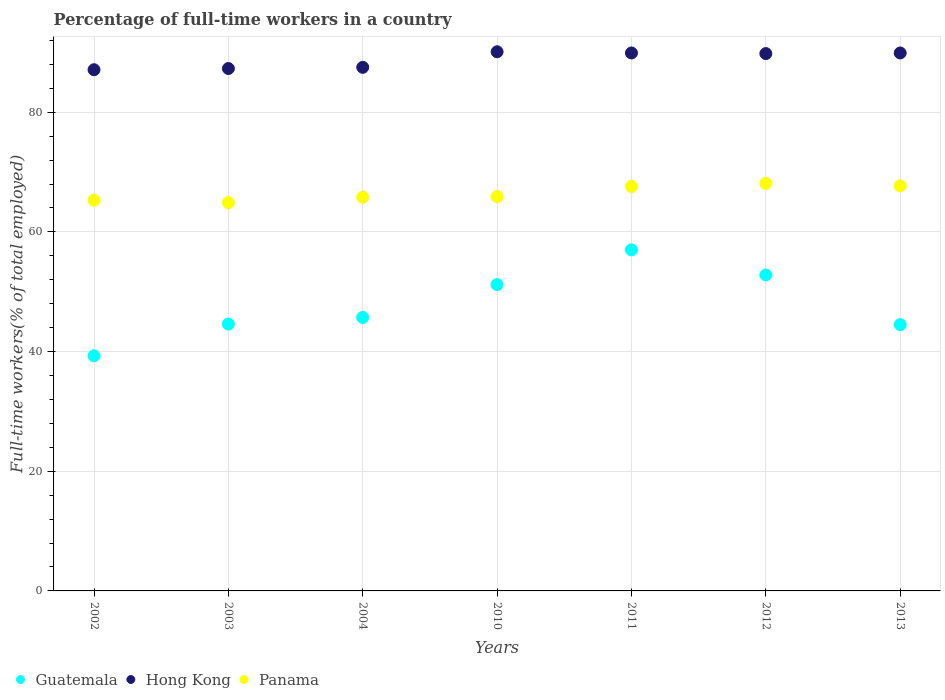What is the percentage of full-time workers in Panama in 2011?
Offer a terse response. 67.6. Across all years, what is the maximum percentage of full-time workers in Guatemala?
Your answer should be compact. 57. Across all years, what is the minimum percentage of full-time workers in Guatemala?
Give a very brief answer. 39.3. In which year was the percentage of full-time workers in Guatemala minimum?
Provide a succinct answer. 2002. What is the total percentage of full-time workers in Guatemala in the graph?
Provide a short and direct response. 335.1. What is the difference between the percentage of full-time workers in Guatemala in 2002 and that in 2003?
Provide a succinct answer. -5.3. What is the difference between the percentage of full-time workers in Hong Kong in 2003 and the percentage of full-time workers in Panama in 2013?
Your answer should be very brief. 19.6. What is the average percentage of full-time workers in Guatemala per year?
Keep it short and to the point. 47.87. In the year 2011, what is the difference between the percentage of full-time workers in Guatemala and percentage of full-time workers in Hong Kong?
Your answer should be compact. -32.9. What is the ratio of the percentage of full-time workers in Panama in 2011 to that in 2012?
Offer a very short reply. 0.99. Is the percentage of full-time workers in Panama in 2002 less than that in 2012?
Your answer should be compact. Yes. What is the difference between the highest and the second highest percentage of full-time workers in Panama?
Offer a terse response. 0.4. What is the difference between the highest and the lowest percentage of full-time workers in Panama?
Ensure brevity in your answer.  3.2. In how many years, is the percentage of full-time workers in Panama greater than the average percentage of full-time workers in Panama taken over all years?
Make the answer very short. 3. Is it the case that in every year, the sum of the percentage of full-time workers in Hong Kong and percentage of full-time workers in Panama  is greater than the percentage of full-time workers in Guatemala?
Provide a short and direct response. Yes. Is the percentage of full-time workers in Hong Kong strictly greater than the percentage of full-time workers in Panama over the years?
Your answer should be very brief. Yes. How many dotlines are there?
Provide a succinct answer. 3. What is the difference between two consecutive major ticks on the Y-axis?
Offer a terse response. 20. Does the graph contain grids?
Keep it short and to the point. Yes. How many legend labels are there?
Ensure brevity in your answer.  3. What is the title of the graph?
Provide a short and direct response. Percentage of full-time workers in a country. What is the label or title of the Y-axis?
Make the answer very short. Full-time workers(% of total employed). What is the Full-time workers(% of total employed) of Guatemala in 2002?
Offer a terse response. 39.3. What is the Full-time workers(% of total employed) of Hong Kong in 2002?
Make the answer very short. 87.1. What is the Full-time workers(% of total employed) of Panama in 2002?
Your answer should be compact. 65.3. What is the Full-time workers(% of total employed) in Guatemala in 2003?
Your answer should be very brief. 44.6. What is the Full-time workers(% of total employed) in Hong Kong in 2003?
Offer a terse response. 87.3. What is the Full-time workers(% of total employed) of Panama in 2003?
Give a very brief answer. 64.9. What is the Full-time workers(% of total employed) in Guatemala in 2004?
Offer a very short reply. 45.7. What is the Full-time workers(% of total employed) in Hong Kong in 2004?
Your response must be concise. 87.5. What is the Full-time workers(% of total employed) in Panama in 2004?
Offer a terse response. 65.8. What is the Full-time workers(% of total employed) in Guatemala in 2010?
Make the answer very short. 51.2. What is the Full-time workers(% of total employed) in Hong Kong in 2010?
Keep it short and to the point. 90.1. What is the Full-time workers(% of total employed) of Panama in 2010?
Ensure brevity in your answer.  65.9. What is the Full-time workers(% of total employed) of Guatemala in 2011?
Offer a very short reply. 57. What is the Full-time workers(% of total employed) in Hong Kong in 2011?
Your response must be concise. 89.9. What is the Full-time workers(% of total employed) in Panama in 2011?
Ensure brevity in your answer.  67.6. What is the Full-time workers(% of total employed) of Guatemala in 2012?
Offer a terse response. 52.8. What is the Full-time workers(% of total employed) in Hong Kong in 2012?
Provide a succinct answer. 89.8. What is the Full-time workers(% of total employed) in Panama in 2012?
Give a very brief answer. 68.1. What is the Full-time workers(% of total employed) of Guatemala in 2013?
Your answer should be compact. 44.5. What is the Full-time workers(% of total employed) in Hong Kong in 2013?
Provide a short and direct response. 89.9. What is the Full-time workers(% of total employed) in Panama in 2013?
Ensure brevity in your answer.  67.7. Across all years, what is the maximum Full-time workers(% of total employed) of Hong Kong?
Provide a succinct answer. 90.1. Across all years, what is the maximum Full-time workers(% of total employed) of Panama?
Your response must be concise. 68.1. Across all years, what is the minimum Full-time workers(% of total employed) of Guatemala?
Your answer should be very brief. 39.3. Across all years, what is the minimum Full-time workers(% of total employed) in Hong Kong?
Your answer should be very brief. 87.1. Across all years, what is the minimum Full-time workers(% of total employed) of Panama?
Provide a succinct answer. 64.9. What is the total Full-time workers(% of total employed) of Guatemala in the graph?
Ensure brevity in your answer.  335.1. What is the total Full-time workers(% of total employed) in Hong Kong in the graph?
Provide a succinct answer. 621.6. What is the total Full-time workers(% of total employed) in Panama in the graph?
Offer a terse response. 465.3. What is the difference between the Full-time workers(% of total employed) in Guatemala in 2002 and that in 2003?
Ensure brevity in your answer.  -5.3. What is the difference between the Full-time workers(% of total employed) of Hong Kong in 2002 and that in 2003?
Keep it short and to the point. -0.2. What is the difference between the Full-time workers(% of total employed) in Guatemala in 2002 and that in 2004?
Keep it short and to the point. -6.4. What is the difference between the Full-time workers(% of total employed) of Hong Kong in 2002 and that in 2004?
Make the answer very short. -0.4. What is the difference between the Full-time workers(% of total employed) of Guatemala in 2002 and that in 2010?
Make the answer very short. -11.9. What is the difference between the Full-time workers(% of total employed) of Panama in 2002 and that in 2010?
Your answer should be compact. -0.6. What is the difference between the Full-time workers(% of total employed) of Guatemala in 2002 and that in 2011?
Keep it short and to the point. -17.7. What is the difference between the Full-time workers(% of total employed) in Hong Kong in 2002 and that in 2011?
Offer a very short reply. -2.8. What is the difference between the Full-time workers(% of total employed) in Panama in 2002 and that in 2012?
Your answer should be very brief. -2.8. What is the difference between the Full-time workers(% of total employed) in Guatemala in 2002 and that in 2013?
Your answer should be very brief. -5.2. What is the difference between the Full-time workers(% of total employed) in Hong Kong in 2002 and that in 2013?
Your answer should be compact. -2.8. What is the difference between the Full-time workers(% of total employed) of Panama in 2002 and that in 2013?
Your answer should be very brief. -2.4. What is the difference between the Full-time workers(% of total employed) in Panama in 2003 and that in 2004?
Keep it short and to the point. -0.9. What is the difference between the Full-time workers(% of total employed) in Guatemala in 2003 and that in 2010?
Your answer should be compact. -6.6. What is the difference between the Full-time workers(% of total employed) of Panama in 2003 and that in 2010?
Your response must be concise. -1. What is the difference between the Full-time workers(% of total employed) of Guatemala in 2003 and that in 2012?
Provide a short and direct response. -8.2. What is the difference between the Full-time workers(% of total employed) in Hong Kong in 2003 and that in 2012?
Your answer should be compact. -2.5. What is the difference between the Full-time workers(% of total employed) in Panama in 2003 and that in 2012?
Offer a very short reply. -3.2. What is the difference between the Full-time workers(% of total employed) of Guatemala in 2003 and that in 2013?
Your answer should be compact. 0.1. What is the difference between the Full-time workers(% of total employed) in Panama in 2003 and that in 2013?
Offer a very short reply. -2.8. What is the difference between the Full-time workers(% of total employed) in Guatemala in 2004 and that in 2010?
Provide a succinct answer. -5.5. What is the difference between the Full-time workers(% of total employed) in Hong Kong in 2004 and that in 2010?
Your answer should be compact. -2.6. What is the difference between the Full-time workers(% of total employed) of Hong Kong in 2004 and that in 2012?
Provide a short and direct response. -2.3. What is the difference between the Full-time workers(% of total employed) in Hong Kong in 2004 and that in 2013?
Ensure brevity in your answer.  -2.4. What is the difference between the Full-time workers(% of total employed) in Panama in 2004 and that in 2013?
Provide a short and direct response. -1.9. What is the difference between the Full-time workers(% of total employed) in Guatemala in 2010 and that in 2011?
Your answer should be very brief. -5.8. What is the difference between the Full-time workers(% of total employed) of Panama in 2010 and that in 2011?
Offer a very short reply. -1.7. What is the difference between the Full-time workers(% of total employed) in Guatemala in 2010 and that in 2013?
Provide a short and direct response. 6.7. What is the difference between the Full-time workers(% of total employed) in Panama in 2010 and that in 2013?
Offer a very short reply. -1.8. What is the difference between the Full-time workers(% of total employed) of Guatemala in 2011 and that in 2013?
Keep it short and to the point. 12.5. What is the difference between the Full-time workers(% of total employed) of Hong Kong in 2011 and that in 2013?
Your answer should be compact. 0. What is the difference between the Full-time workers(% of total employed) in Hong Kong in 2012 and that in 2013?
Provide a short and direct response. -0.1. What is the difference between the Full-time workers(% of total employed) of Guatemala in 2002 and the Full-time workers(% of total employed) of Hong Kong in 2003?
Make the answer very short. -48. What is the difference between the Full-time workers(% of total employed) of Guatemala in 2002 and the Full-time workers(% of total employed) of Panama in 2003?
Provide a succinct answer. -25.6. What is the difference between the Full-time workers(% of total employed) in Guatemala in 2002 and the Full-time workers(% of total employed) in Hong Kong in 2004?
Your answer should be very brief. -48.2. What is the difference between the Full-time workers(% of total employed) of Guatemala in 2002 and the Full-time workers(% of total employed) of Panama in 2004?
Your answer should be compact. -26.5. What is the difference between the Full-time workers(% of total employed) in Hong Kong in 2002 and the Full-time workers(% of total employed) in Panama in 2004?
Provide a short and direct response. 21.3. What is the difference between the Full-time workers(% of total employed) of Guatemala in 2002 and the Full-time workers(% of total employed) of Hong Kong in 2010?
Offer a terse response. -50.8. What is the difference between the Full-time workers(% of total employed) of Guatemala in 2002 and the Full-time workers(% of total employed) of Panama in 2010?
Your response must be concise. -26.6. What is the difference between the Full-time workers(% of total employed) in Hong Kong in 2002 and the Full-time workers(% of total employed) in Panama in 2010?
Make the answer very short. 21.2. What is the difference between the Full-time workers(% of total employed) of Guatemala in 2002 and the Full-time workers(% of total employed) of Hong Kong in 2011?
Offer a very short reply. -50.6. What is the difference between the Full-time workers(% of total employed) of Guatemala in 2002 and the Full-time workers(% of total employed) of Panama in 2011?
Your answer should be very brief. -28.3. What is the difference between the Full-time workers(% of total employed) of Guatemala in 2002 and the Full-time workers(% of total employed) of Hong Kong in 2012?
Provide a succinct answer. -50.5. What is the difference between the Full-time workers(% of total employed) of Guatemala in 2002 and the Full-time workers(% of total employed) of Panama in 2012?
Your answer should be very brief. -28.8. What is the difference between the Full-time workers(% of total employed) of Guatemala in 2002 and the Full-time workers(% of total employed) of Hong Kong in 2013?
Give a very brief answer. -50.6. What is the difference between the Full-time workers(% of total employed) of Guatemala in 2002 and the Full-time workers(% of total employed) of Panama in 2013?
Your answer should be compact. -28.4. What is the difference between the Full-time workers(% of total employed) in Hong Kong in 2002 and the Full-time workers(% of total employed) in Panama in 2013?
Make the answer very short. 19.4. What is the difference between the Full-time workers(% of total employed) in Guatemala in 2003 and the Full-time workers(% of total employed) in Hong Kong in 2004?
Ensure brevity in your answer.  -42.9. What is the difference between the Full-time workers(% of total employed) of Guatemala in 2003 and the Full-time workers(% of total employed) of Panama in 2004?
Give a very brief answer. -21.2. What is the difference between the Full-time workers(% of total employed) of Guatemala in 2003 and the Full-time workers(% of total employed) of Hong Kong in 2010?
Provide a succinct answer. -45.5. What is the difference between the Full-time workers(% of total employed) of Guatemala in 2003 and the Full-time workers(% of total employed) of Panama in 2010?
Keep it short and to the point. -21.3. What is the difference between the Full-time workers(% of total employed) in Hong Kong in 2003 and the Full-time workers(% of total employed) in Panama in 2010?
Provide a succinct answer. 21.4. What is the difference between the Full-time workers(% of total employed) in Guatemala in 2003 and the Full-time workers(% of total employed) in Hong Kong in 2011?
Provide a succinct answer. -45.3. What is the difference between the Full-time workers(% of total employed) of Hong Kong in 2003 and the Full-time workers(% of total employed) of Panama in 2011?
Your answer should be very brief. 19.7. What is the difference between the Full-time workers(% of total employed) of Guatemala in 2003 and the Full-time workers(% of total employed) of Hong Kong in 2012?
Offer a terse response. -45.2. What is the difference between the Full-time workers(% of total employed) in Guatemala in 2003 and the Full-time workers(% of total employed) in Panama in 2012?
Offer a terse response. -23.5. What is the difference between the Full-time workers(% of total employed) in Guatemala in 2003 and the Full-time workers(% of total employed) in Hong Kong in 2013?
Offer a very short reply. -45.3. What is the difference between the Full-time workers(% of total employed) in Guatemala in 2003 and the Full-time workers(% of total employed) in Panama in 2013?
Provide a short and direct response. -23.1. What is the difference between the Full-time workers(% of total employed) of Hong Kong in 2003 and the Full-time workers(% of total employed) of Panama in 2013?
Your answer should be compact. 19.6. What is the difference between the Full-time workers(% of total employed) of Guatemala in 2004 and the Full-time workers(% of total employed) of Hong Kong in 2010?
Make the answer very short. -44.4. What is the difference between the Full-time workers(% of total employed) in Guatemala in 2004 and the Full-time workers(% of total employed) in Panama in 2010?
Offer a terse response. -20.2. What is the difference between the Full-time workers(% of total employed) of Hong Kong in 2004 and the Full-time workers(% of total employed) of Panama in 2010?
Make the answer very short. 21.6. What is the difference between the Full-time workers(% of total employed) of Guatemala in 2004 and the Full-time workers(% of total employed) of Hong Kong in 2011?
Keep it short and to the point. -44.2. What is the difference between the Full-time workers(% of total employed) in Guatemala in 2004 and the Full-time workers(% of total employed) in Panama in 2011?
Keep it short and to the point. -21.9. What is the difference between the Full-time workers(% of total employed) in Guatemala in 2004 and the Full-time workers(% of total employed) in Hong Kong in 2012?
Make the answer very short. -44.1. What is the difference between the Full-time workers(% of total employed) of Guatemala in 2004 and the Full-time workers(% of total employed) of Panama in 2012?
Keep it short and to the point. -22.4. What is the difference between the Full-time workers(% of total employed) of Hong Kong in 2004 and the Full-time workers(% of total employed) of Panama in 2012?
Offer a terse response. 19.4. What is the difference between the Full-time workers(% of total employed) in Guatemala in 2004 and the Full-time workers(% of total employed) in Hong Kong in 2013?
Your response must be concise. -44.2. What is the difference between the Full-time workers(% of total employed) in Hong Kong in 2004 and the Full-time workers(% of total employed) in Panama in 2013?
Provide a short and direct response. 19.8. What is the difference between the Full-time workers(% of total employed) of Guatemala in 2010 and the Full-time workers(% of total employed) of Hong Kong in 2011?
Provide a succinct answer. -38.7. What is the difference between the Full-time workers(% of total employed) in Guatemala in 2010 and the Full-time workers(% of total employed) in Panama in 2011?
Your answer should be compact. -16.4. What is the difference between the Full-time workers(% of total employed) of Hong Kong in 2010 and the Full-time workers(% of total employed) of Panama in 2011?
Make the answer very short. 22.5. What is the difference between the Full-time workers(% of total employed) of Guatemala in 2010 and the Full-time workers(% of total employed) of Hong Kong in 2012?
Provide a short and direct response. -38.6. What is the difference between the Full-time workers(% of total employed) of Guatemala in 2010 and the Full-time workers(% of total employed) of Panama in 2012?
Provide a short and direct response. -16.9. What is the difference between the Full-time workers(% of total employed) of Hong Kong in 2010 and the Full-time workers(% of total employed) of Panama in 2012?
Offer a very short reply. 22. What is the difference between the Full-time workers(% of total employed) of Guatemala in 2010 and the Full-time workers(% of total employed) of Hong Kong in 2013?
Offer a very short reply. -38.7. What is the difference between the Full-time workers(% of total employed) in Guatemala in 2010 and the Full-time workers(% of total employed) in Panama in 2013?
Ensure brevity in your answer.  -16.5. What is the difference between the Full-time workers(% of total employed) of Hong Kong in 2010 and the Full-time workers(% of total employed) of Panama in 2013?
Provide a short and direct response. 22.4. What is the difference between the Full-time workers(% of total employed) in Guatemala in 2011 and the Full-time workers(% of total employed) in Hong Kong in 2012?
Your answer should be compact. -32.8. What is the difference between the Full-time workers(% of total employed) in Hong Kong in 2011 and the Full-time workers(% of total employed) in Panama in 2012?
Give a very brief answer. 21.8. What is the difference between the Full-time workers(% of total employed) of Guatemala in 2011 and the Full-time workers(% of total employed) of Hong Kong in 2013?
Give a very brief answer. -32.9. What is the difference between the Full-time workers(% of total employed) of Guatemala in 2011 and the Full-time workers(% of total employed) of Panama in 2013?
Your answer should be very brief. -10.7. What is the difference between the Full-time workers(% of total employed) of Hong Kong in 2011 and the Full-time workers(% of total employed) of Panama in 2013?
Your answer should be compact. 22.2. What is the difference between the Full-time workers(% of total employed) in Guatemala in 2012 and the Full-time workers(% of total employed) in Hong Kong in 2013?
Make the answer very short. -37.1. What is the difference between the Full-time workers(% of total employed) of Guatemala in 2012 and the Full-time workers(% of total employed) of Panama in 2013?
Make the answer very short. -14.9. What is the difference between the Full-time workers(% of total employed) in Hong Kong in 2012 and the Full-time workers(% of total employed) in Panama in 2013?
Your response must be concise. 22.1. What is the average Full-time workers(% of total employed) of Guatemala per year?
Your answer should be very brief. 47.87. What is the average Full-time workers(% of total employed) of Hong Kong per year?
Ensure brevity in your answer.  88.8. What is the average Full-time workers(% of total employed) in Panama per year?
Provide a short and direct response. 66.47. In the year 2002, what is the difference between the Full-time workers(% of total employed) of Guatemala and Full-time workers(% of total employed) of Hong Kong?
Offer a terse response. -47.8. In the year 2002, what is the difference between the Full-time workers(% of total employed) in Hong Kong and Full-time workers(% of total employed) in Panama?
Provide a short and direct response. 21.8. In the year 2003, what is the difference between the Full-time workers(% of total employed) of Guatemala and Full-time workers(% of total employed) of Hong Kong?
Ensure brevity in your answer.  -42.7. In the year 2003, what is the difference between the Full-time workers(% of total employed) of Guatemala and Full-time workers(% of total employed) of Panama?
Offer a very short reply. -20.3. In the year 2003, what is the difference between the Full-time workers(% of total employed) of Hong Kong and Full-time workers(% of total employed) of Panama?
Make the answer very short. 22.4. In the year 2004, what is the difference between the Full-time workers(% of total employed) of Guatemala and Full-time workers(% of total employed) of Hong Kong?
Offer a very short reply. -41.8. In the year 2004, what is the difference between the Full-time workers(% of total employed) of Guatemala and Full-time workers(% of total employed) of Panama?
Give a very brief answer. -20.1. In the year 2004, what is the difference between the Full-time workers(% of total employed) in Hong Kong and Full-time workers(% of total employed) in Panama?
Your answer should be compact. 21.7. In the year 2010, what is the difference between the Full-time workers(% of total employed) in Guatemala and Full-time workers(% of total employed) in Hong Kong?
Offer a terse response. -38.9. In the year 2010, what is the difference between the Full-time workers(% of total employed) in Guatemala and Full-time workers(% of total employed) in Panama?
Offer a terse response. -14.7. In the year 2010, what is the difference between the Full-time workers(% of total employed) in Hong Kong and Full-time workers(% of total employed) in Panama?
Make the answer very short. 24.2. In the year 2011, what is the difference between the Full-time workers(% of total employed) in Guatemala and Full-time workers(% of total employed) in Hong Kong?
Provide a succinct answer. -32.9. In the year 2011, what is the difference between the Full-time workers(% of total employed) in Guatemala and Full-time workers(% of total employed) in Panama?
Provide a succinct answer. -10.6. In the year 2011, what is the difference between the Full-time workers(% of total employed) in Hong Kong and Full-time workers(% of total employed) in Panama?
Make the answer very short. 22.3. In the year 2012, what is the difference between the Full-time workers(% of total employed) of Guatemala and Full-time workers(% of total employed) of Hong Kong?
Your answer should be very brief. -37. In the year 2012, what is the difference between the Full-time workers(% of total employed) of Guatemala and Full-time workers(% of total employed) of Panama?
Provide a short and direct response. -15.3. In the year 2012, what is the difference between the Full-time workers(% of total employed) in Hong Kong and Full-time workers(% of total employed) in Panama?
Your answer should be very brief. 21.7. In the year 2013, what is the difference between the Full-time workers(% of total employed) of Guatemala and Full-time workers(% of total employed) of Hong Kong?
Ensure brevity in your answer.  -45.4. In the year 2013, what is the difference between the Full-time workers(% of total employed) of Guatemala and Full-time workers(% of total employed) of Panama?
Offer a very short reply. -23.2. In the year 2013, what is the difference between the Full-time workers(% of total employed) of Hong Kong and Full-time workers(% of total employed) of Panama?
Make the answer very short. 22.2. What is the ratio of the Full-time workers(% of total employed) in Guatemala in 2002 to that in 2003?
Your response must be concise. 0.88. What is the ratio of the Full-time workers(% of total employed) in Hong Kong in 2002 to that in 2003?
Offer a very short reply. 1. What is the ratio of the Full-time workers(% of total employed) in Panama in 2002 to that in 2003?
Keep it short and to the point. 1.01. What is the ratio of the Full-time workers(% of total employed) in Guatemala in 2002 to that in 2004?
Offer a very short reply. 0.86. What is the ratio of the Full-time workers(% of total employed) of Hong Kong in 2002 to that in 2004?
Make the answer very short. 1. What is the ratio of the Full-time workers(% of total employed) of Panama in 2002 to that in 2004?
Make the answer very short. 0.99. What is the ratio of the Full-time workers(% of total employed) of Guatemala in 2002 to that in 2010?
Offer a very short reply. 0.77. What is the ratio of the Full-time workers(% of total employed) in Hong Kong in 2002 to that in 2010?
Offer a very short reply. 0.97. What is the ratio of the Full-time workers(% of total employed) of Panama in 2002 to that in 2010?
Provide a succinct answer. 0.99. What is the ratio of the Full-time workers(% of total employed) of Guatemala in 2002 to that in 2011?
Offer a very short reply. 0.69. What is the ratio of the Full-time workers(% of total employed) in Hong Kong in 2002 to that in 2011?
Ensure brevity in your answer.  0.97. What is the ratio of the Full-time workers(% of total employed) of Guatemala in 2002 to that in 2012?
Ensure brevity in your answer.  0.74. What is the ratio of the Full-time workers(% of total employed) of Hong Kong in 2002 to that in 2012?
Your answer should be compact. 0.97. What is the ratio of the Full-time workers(% of total employed) of Panama in 2002 to that in 2012?
Keep it short and to the point. 0.96. What is the ratio of the Full-time workers(% of total employed) in Guatemala in 2002 to that in 2013?
Make the answer very short. 0.88. What is the ratio of the Full-time workers(% of total employed) in Hong Kong in 2002 to that in 2013?
Offer a terse response. 0.97. What is the ratio of the Full-time workers(% of total employed) of Panama in 2002 to that in 2013?
Offer a very short reply. 0.96. What is the ratio of the Full-time workers(% of total employed) in Guatemala in 2003 to that in 2004?
Your answer should be very brief. 0.98. What is the ratio of the Full-time workers(% of total employed) in Panama in 2003 to that in 2004?
Offer a terse response. 0.99. What is the ratio of the Full-time workers(% of total employed) of Guatemala in 2003 to that in 2010?
Provide a succinct answer. 0.87. What is the ratio of the Full-time workers(% of total employed) of Hong Kong in 2003 to that in 2010?
Offer a very short reply. 0.97. What is the ratio of the Full-time workers(% of total employed) of Guatemala in 2003 to that in 2011?
Offer a very short reply. 0.78. What is the ratio of the Full-time workers(% of total employed) of Hong Kong in 2003 to that in 2011?
Make the answer very short. 0.97. What is the ratio of the Full-time workers(% of total employed) of Panama in 2003 to that in 2011?
Provide a short and direct response. 0.96. What is the ratio of the Full-time workers(% of total employed) of Guatemala in 2003 to that in 2012?
Offer a terse response. 0.84. What is the ratio of the Full-time workers(% of total employed) in Hong Kong in 2003 to that in 2012?
Your answer should be very brief. 0.97. What is the ratio of the Full-time workers(% of total employed) of Panama in 2003 to that in 2012?
Give a very brief answer. 0.95. What is the ratio of the Full-time workers(% of total employed) of Guatemala in 2003 to that in 2013?
Keep it short and to the point. 1. What is the ratio of the Full-time workers(% of total employed) of Hong Kong in 2003 to that in 2013?
Your answer should be compact. 0.97. What is the ratio of the Full-time workers(% of total employed) of Panama in 2003 to that in 2013?
Offer a very short reply. 0.96. What is the ratio of the Full-time workers(% of total employed) of Guatemala in 2004 to that in 2010?
Offer a terse response. 0.89. What is the ratio of the Full-time workers(% of total employed) of Hong Kong in 2004 to that in 2010?
Your answer should be compact. 0.97. What is the ratio of the Full-time workers(% of total employed) of Panama in 2004 to that in 2010?
Provide a short and direct response. 1. What is the ratio of the Full-time workers(% of total employed) in Guatemala in 2004 to that in 2011?
Ensure brevity in your answer.  0.8. What is the ratio of the Full-time workers(% of total employed) of Hong Kong in 2004 to that in 2011?
Offer a terse response. 0.97. What is the ratio of the Full-time workers(% of total employed) of Panama in 2004 to that in 2011?
Your answer should be very brief. 0.97. What is the ratio of the Full-time workers(% of total employed) in Guatemala in 2004 to that in 2012?
Make the answer very short. 0.87. What is the ratio of the Full-time workers(% of total employed) in Hong Kong in 2004 to that in 2012?
Your response must be concise. 0.97. What is the ratio of the Full-time workers(% of total employed) in Panama in 2004 to that in 2012?
Give a very brief answer. 0.97. What is the ratio of the Full-time workers(% of total employed) of Hong Kong in 2004 to that in 2013?
Provide a short and direct response. 0.97. What is the ratio of the Full-time workers(% of total employed) of Panama in 2004 to that in 2013?
Give a very brief answer. 0.97. What is the ratio of the Full-time workers(% of total employed) in Guatemala in 2010 to that in 2011?
Ensure brevity in your answer.  0.9. What is the ratio of the Full-time workers(% of total employed) in Hong Kong in 2010 to that in 2011?
Provide a short and direct response. 1. What is the ratio of the Full-time workers(% of total employed) of Panama in 2010 to that in 2011?
Offer a very short reply. 0.97. What is the ratio of the Full-time workers(% of total employed) of Guatemala in 2010 to that in 2012?
Provide a short and direct response. 0.97. What is the ratio of the Full-time workers(% of total employed) in Hong Kong in 2010 to that in 2012?
Offer a very short reply. 1. What is the ratio of the Full-time workers(% of total employed) of Panama in 2010 to that in 2012?
Your response must be concise. 0.97. What is the ratio of the Full-time workers(% of total employed) of Guatemala in 2010 to that in 2013?
Your answer should be very brief. 1.15. What is the ratio of the Full-time workers(% of total employed) in Hong Kong in 2010 to that in 2013?
Provide a succinct answer. 1. What is the ratio of the Full-time workers(% of total employed) in Panama in 2010 to that in 2013?
Provide a succinct answer. 0.97. What is the ratio of the Full-time workers(% of total employed) in Guatemala in 2011 to that in 2012?
Offer a very short reply. 1.08. What is the ratio of the Full-time workers(% of total employed) in Hong Kong in 2011 to that in 2012?
Give a very brief answer. 1. What is the ratio of the Full-time workers(% of total employed) in Guatemala in 2011 to that in 2013?
Your answer should be very brief. 1.28. What is the ratio of the Full-time workers(% of total employed) of Hong Kong in 2011 to that in 2013?
Make the answer very short. 1. What is the ratio of the Full-time workers(% of total employed) of Panama in 2011 to that in 2013?
Ensure brevity in your answer.  1. What is the ratio of the Full-time workers(% of total employed) of Guatemala in 2012 to that in 2013?
Make the answer very short. 1.19. What is the ratio of the Full-time workers(% of total employed) in Panama in 2012 to that in 2013?
Provide a short and direct response. 1.01. What is the difference between the highest and the second highest Full-time workers(% of total employed) in Hong Kong?
Offer a very short reply. 0.2. What is the difference between the highest and the second highest Full-time workers(% of total employed) in Panama?
Ensure brevity in your answer.  0.4. What is the difference between the highest and the lowest Full-time workers(% of total employed) of Guatemala?
Your answer should be compact. 17.7. 